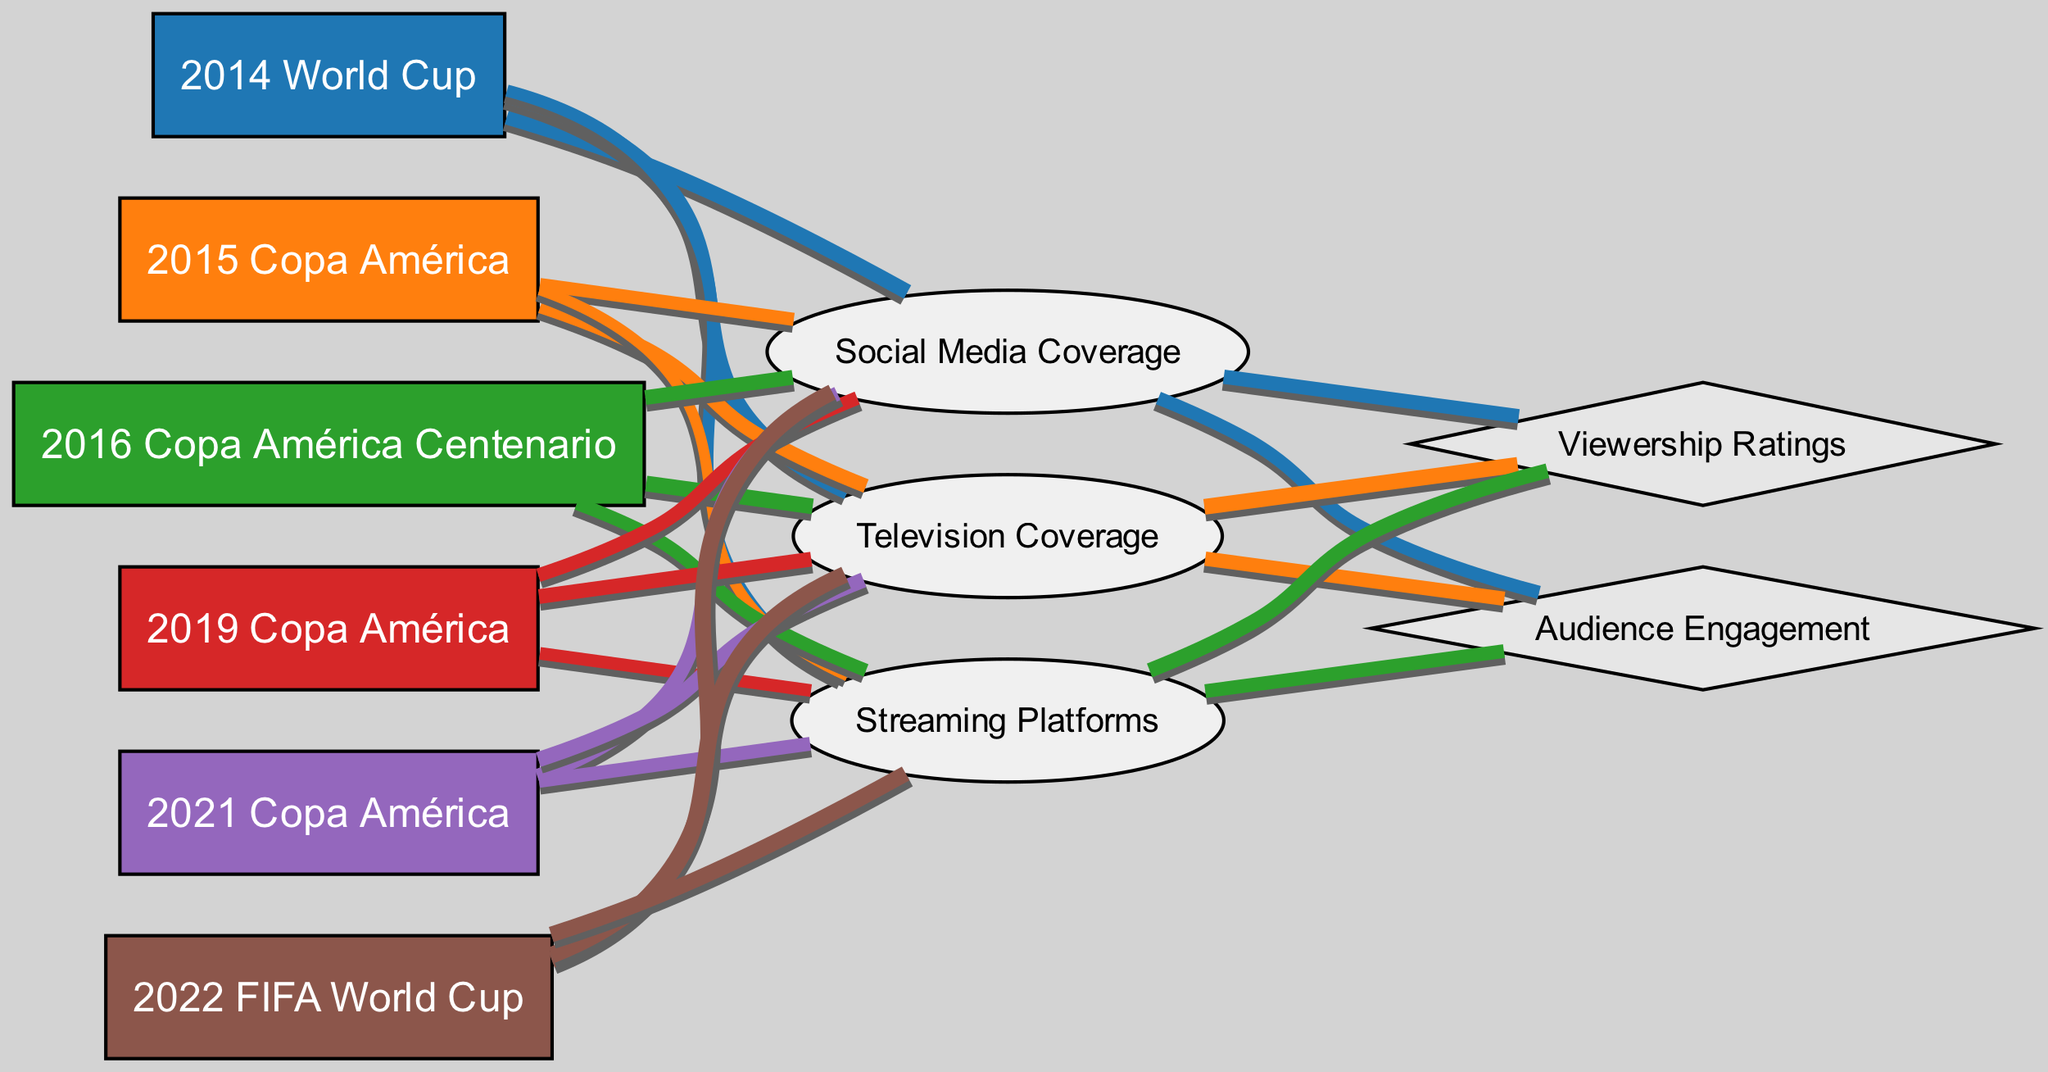What was the media coverage value for the 2021 Copa América on streaming platforms? In the diagram, the 2021 Copa América is linked to the Streaming Platforms node, and the value associated with this link is 65.
Answer: 65 Which tournament had the highest television coverage value? By examining the links from each tournament to the Television Coverage node, the 2022 FIFA World Cup has the highest value of 95.
Answer: 2022 FIFA World Cup What is the total number of events depicted in the diagram? The diagram includes 6 events: 2014 World Cup, 2015 Copa América, 2016 Copa América Centenario, 2019 Copa América, 2021 Copa América, and 2022 FIFA World Cup, making a total of 6 events.
Answer: 6 How does the audience engagement link from the 2014 World Cup compare to that of the 2019 Copa América? The 2014 World Cup has an Audience Engagement value of 60, while the 2019 Copa América has a value of 55. Therefore, the 2014 World Cup has a higher value than the 2019 Copa América.
Answer: 60 Which media type had the highest total viewership ratings across all events? The links show that Television Coverage has the highest value with a total of 85 from multiple tournaments, compared to Social Media Coverage and Streaming Platforms.
Answer: Television Coverage For the 2016 Copa América, what was the television coverage value compared to the social media coverage value? The television coverage value for the 2016 Copa América is 85, which is greater than the social media coverage value of 75, indicating more viewers opted for television.
Answer: Higher How did the viewership ratings change from the 2014 World Cup to the 2022 FIFA World Cup? The viewership ratings for the 2014 World Cup were 70, while for the 2022 FIFA World Cup, it is 85, showing an increase in interest over the years.
Answer: Increase What percentage of media coverage in the 2015 Copa América was attributed to social media? The social media coverage value for the 2015 Copa América is 60, which when compared to the total media coverage (60 + 70 + 40 = 170), gives a rough 35% attributed to social media.
Answer: 35% Which month of the year would likely see the highest audience engagement, assuming tournaments generally take place around the same time each year? Given that the 2014 World Cup has the highest overall audience engagement of 70, it can be inferred that this event would likely attract the most engagement, especially around June-July when it occurred.
Answer: June-July 